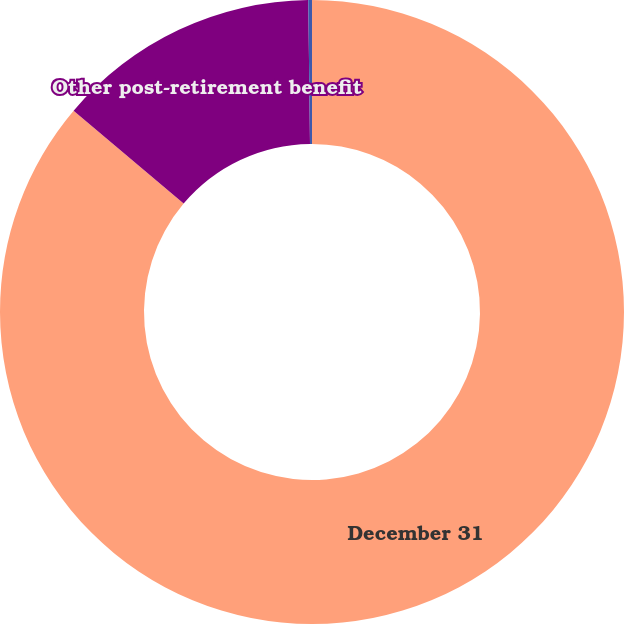Convert chart. <chart><loc_0><loc_0><loc_500><loc_500><pie_chart><fcel>December 31<fcel>Other post-retirement benefit<fcel>Benefit obligations discount<nl><fcel>86.16%<fcel>13.65%<fcel>0.19%<nl></chart> 